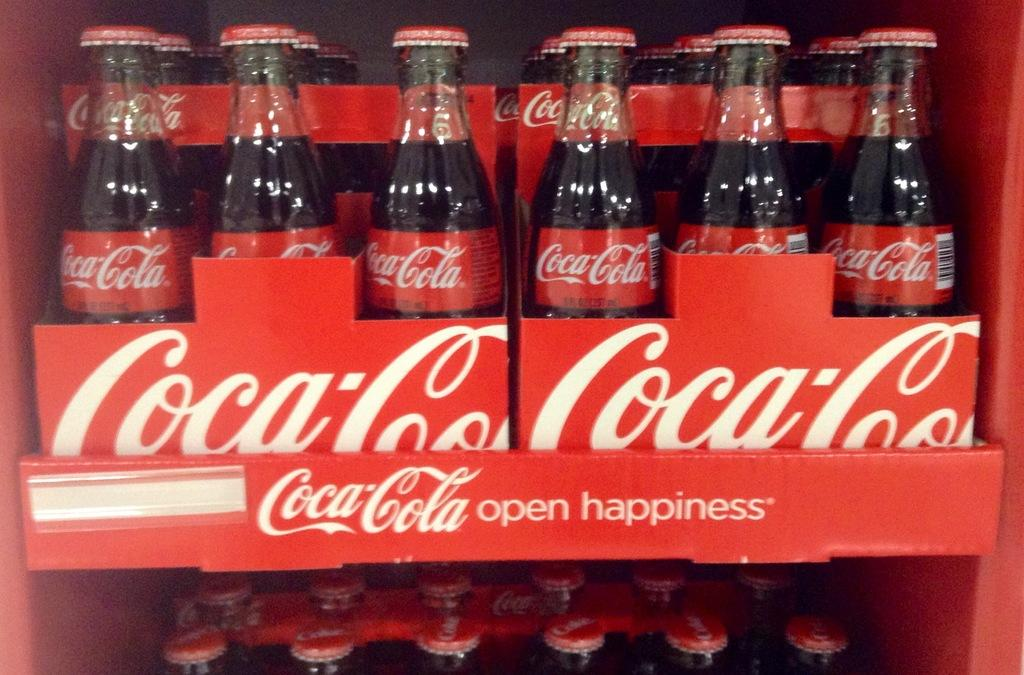What is the main focus of the image? The main focus of the image is preservative drinking bottles. Can you describe the bottles in the image? The bottles are highlighted in the image, suggesting they are the primary subject. What is the grandmother doing in the image? There is no grandmother present in the image; it features preservative drinking bottles. What color are the farmer's eyes in the image? There is no farmer present in the image, and therefore no eyes to describe. 